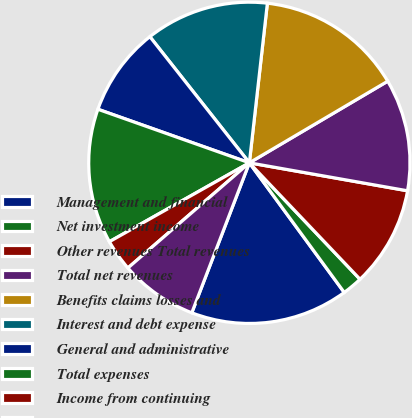<chart> <loc_0><loc_0><loc_500><loc_500><pie_chart><fcel>Management and financial<fcel>Net investment income<fcel>Other revenues Total revenues<fcel>Total net revenues<fcel>Benefits claims losses and<fcel>Interest and debt expense<fcel>General and administrative<fcel>Total expenses<fcel>Income from continuing<fcel>Income tax provision<nl><fcel>15.89%<fcel>2.04%<fcel>10.12%<fcel>11.27%<fcel>14.73%<fcel>12.42%<fcel>8.96%<fcel>13.58%<fcel>3.19%<fcel>7.81%<nl></chart> 